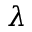<formula> <loc_0><loc_0><loc_500><loc_500>\lambda</formula> 